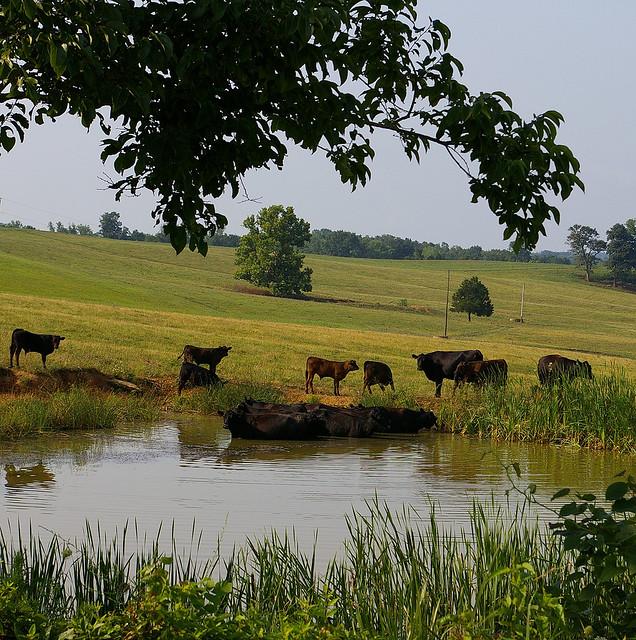Is this a farm?
Keep it brief. Yes. What is in the water?
Be succinct. Cows. Is the ground level?
Short answer required. Yes. 